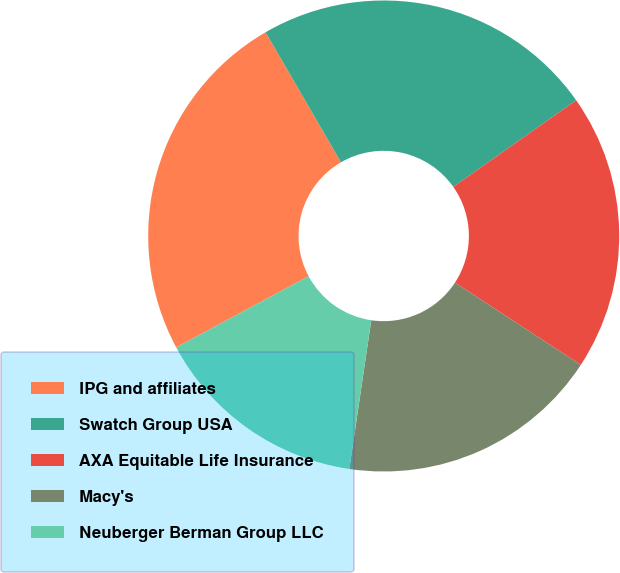Convert chart. <chart><loc_0><loc_0><loc_500><loc_500><pie_chart><fcel>IPG and affiliates<fcel>Swatch Group USA<fcel>AXA Equitable Life Insurance<fcel>Macy's<fcel>Neuberger Berman Group LLC<nl><fcel>24.48%<fcel>23.59%<fcel>19.0%<fcel>18.11%<fcel>14.83%<nl></chart> 